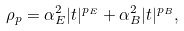<formula> <loc_0><loc_0><loc_500><loc_500>\rho _ { p } = \alpha _ { E } ^ { 2 } | t | ^ { p _ { E } } + \alpha _ { B } ^ { 2 } | t | ^ { p _ { B } } ,</formula> 